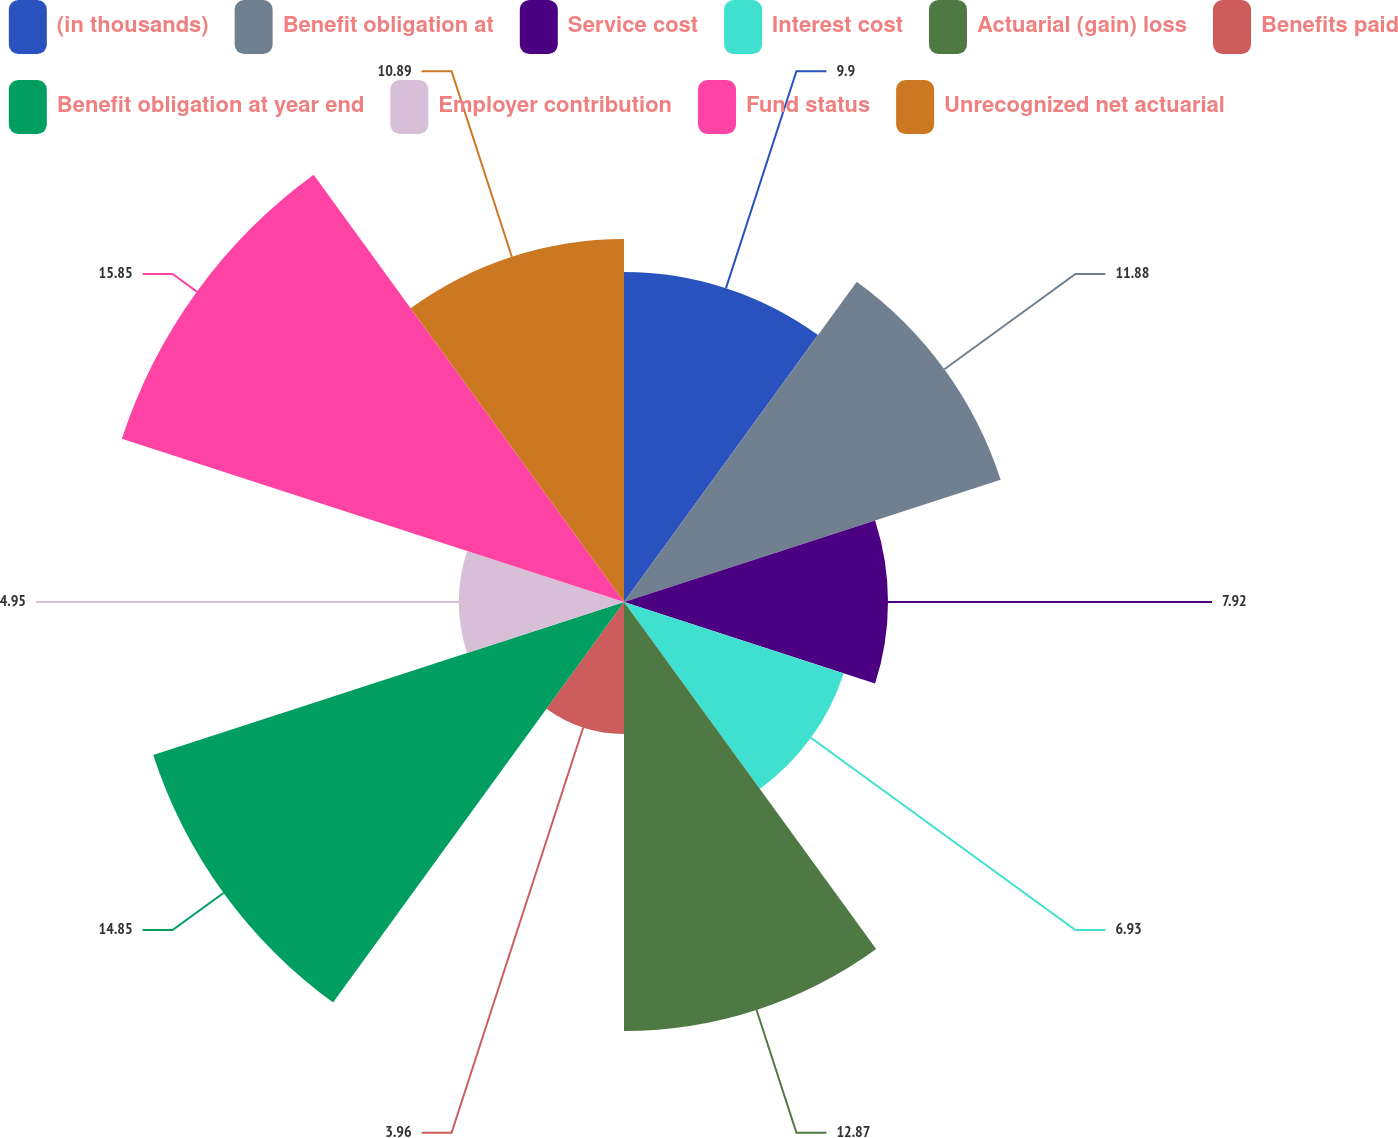Convert chart. <chart><loc_0><loc_0><loc_500><loc_500><pie_chart><fcel>(in thousands)<fcel>Benefit obligation at<fcel>Service cost<fcel>Interest cost<fcel>Actuarial (gain) loss<fcel>Benefits paid<fcel>Benefit obligation at year end<fcel>Employer contribution<fcel>Fund status<fcel>Unrecognized net actuarial<nl><fcel>9.9%<fcel>11.88%<fcel>7.92%<fcel>6.93%<fcel>12.87%<fcel>3.96%<fcel>14.85%<fcel>4.95%<fcel>15.84%<fcel>10.89%<nl></chart> 